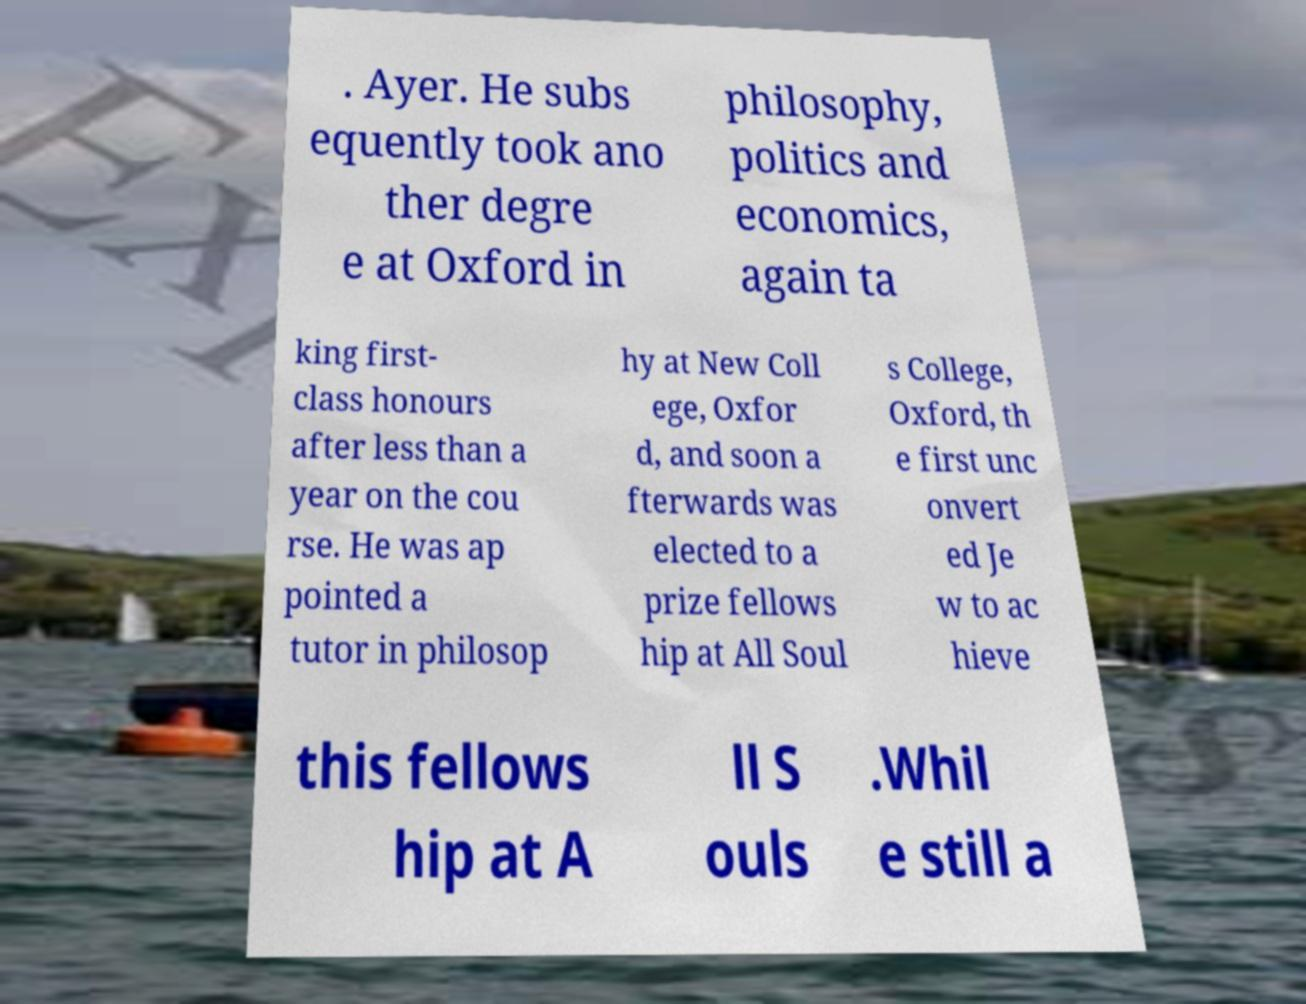Please identify and transcribe the text found in this image. . Ayer. He subs equently took ano ther degre e at Oxford in philosophy, politics and economics, again ta king first- class honours after less than a year on the cou rse. He was ap pointed a tutor in philosop hy at New Coll ege, Oxfor d, and soon a fterwards was elected to a prize fellows hip at All Soul s College, Oxford, th e first unc onvert ed Je w to ac hieve this fellows hip at A ll S ouls .Whil e still a 